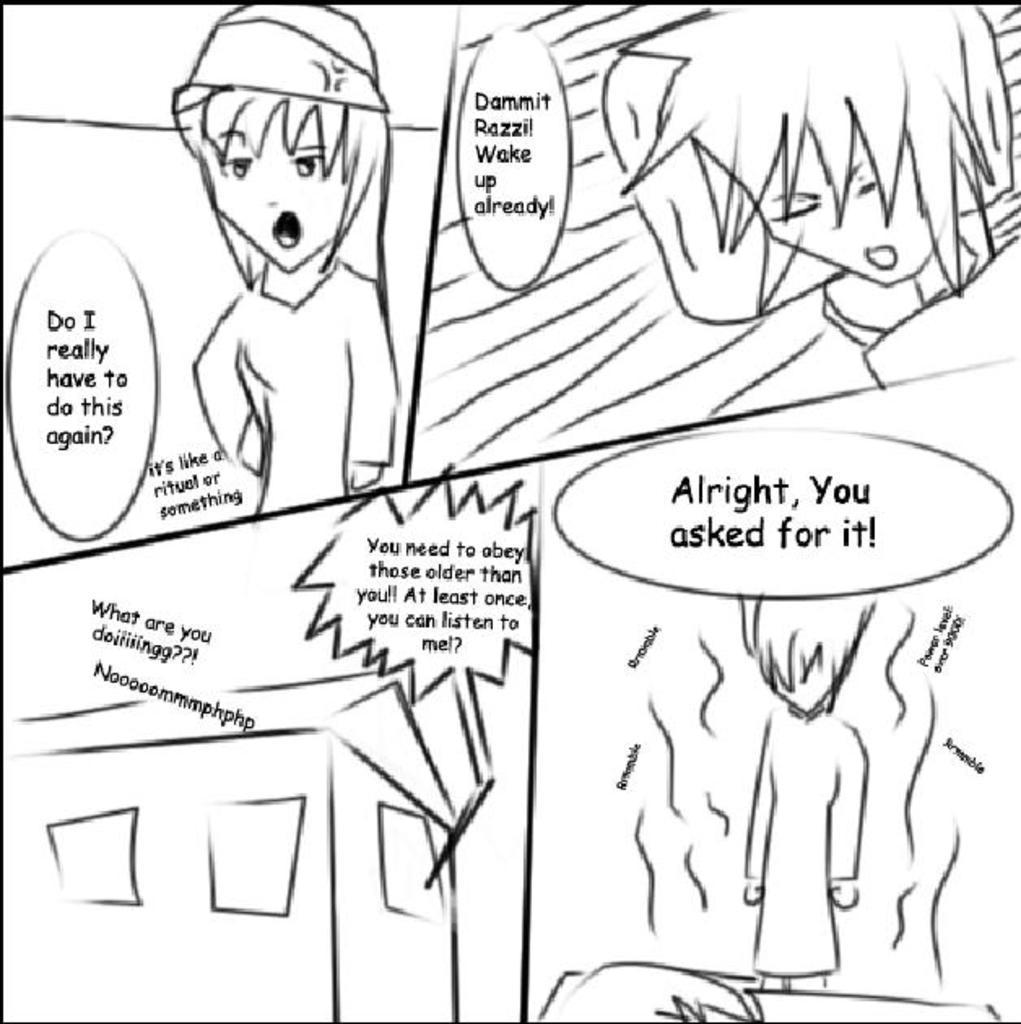Could you give a brief overview of what you see in this image? In this image I can see few cartoon images and something is written on it. Background is in white color. 